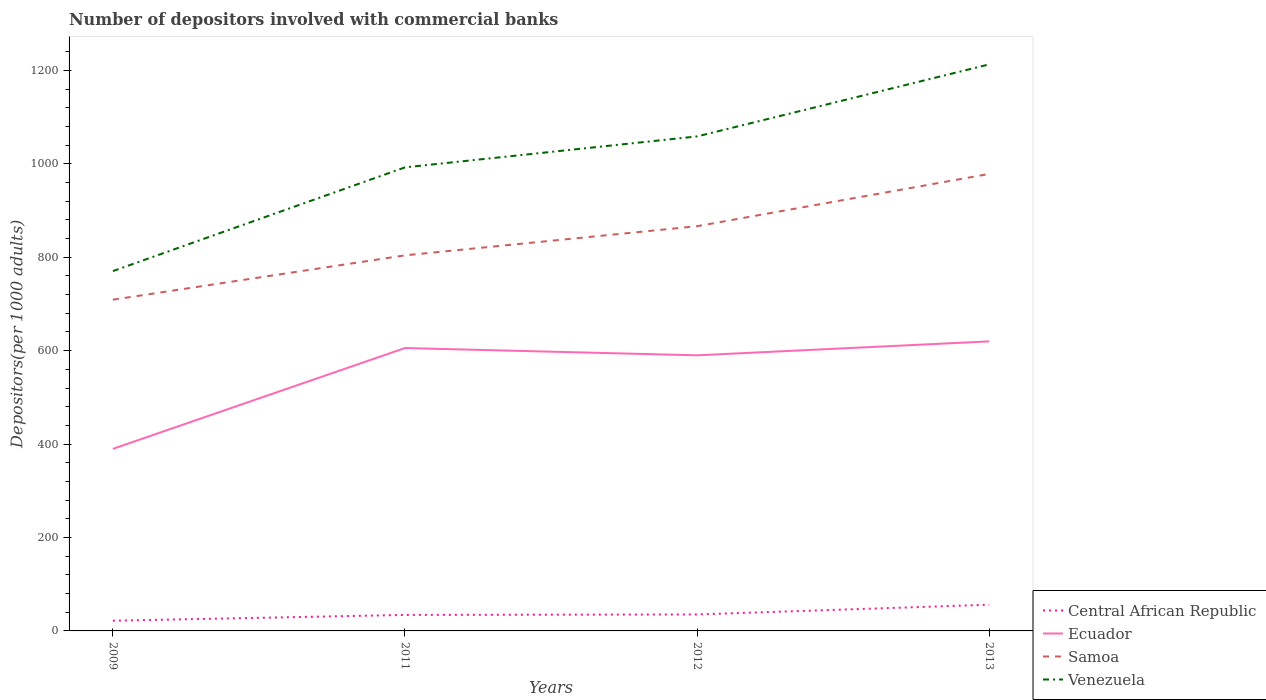Across all years, what is the maximum number of depositors involved with commercial banks in Central African Republic?
Ensure brevity in your answer.  21.85. What is the total number of depositors involved with commercial banks in Central African Republic in the graph?
Give a very brief answer. -12.4. What is the difference between the highest and the second highest number of depositors involved with commercial banks in Central African Republic?
Give a very brief answer. 34.25. What is the difference between the highest and the lowest number of depositors involved with commercial banks in Samoa?
Your answer should be very brief. 2. How many lines are there?
Make the answer very short. 4. How many years are there in the graph?
Your answer should be very brief. 4. What is the difference between two consecutive major ticks on the Y-axis?
Your answer should be very brief. 200. What is the title of the graph?
Your answer should be compact. Number of depositors involved with commercial banks. Does "Liechtenstein" appear as one of the legend labels in the graph?
Your answer should be compact. No. What is the label or title of the Y-axis?
Keep it short and to the point. Depositors(per 1000 adults). What is the Depositors(per 1000 adults) in Central African Republic in 2009?
Keep it short and to the point. 21.85. What is the Depositors(per 1000 adults) of Ecuador in 2009?
Offer a very short reply. 389.78. What is the Depositors(per 1000 adults) of Samoa in 2009?
Offer a terse response. 709.09. What is the Depositors(per 1000 adults) of Venezuela in 2009?
Provide a succinct answer. 770.33. What is the Depositors(per 1000 adults) of Central African Republic in 2011?
Make the answer very short. 34.26. What is the Depositors(per 1000 adults) of Ecuador in 2011?
Provide a succinct answer. 605.63. What is the Depositors(per 1000 adults) of Samoa in 2011?
Keep it short and to the point. 804.04. What is the Depositors(per 1000 adults) of Venezuela in 2011?
Make the answer very short. 992.39. What is the Depositors(per 1000 adults) in Central African Republic in 2012?
Offer a terse response. 35.28. What is the Depositors(per 1000 adults) of Ecuador in 2012?
Your answer should be very brief. 590.02. What is the Depositors(per 1000 adults) of Samoa in 2012?
Ensure brevity in your answer.  866.45. What is the Depositors(per 1000 adults) of Venezuela in 2012?
Keep it short and to the point. 1058.65. What is the Depositors(per 1000 adults) in Central African Republic in 2013?
Your response must be concise. 56.1. What is the Depositors(per 1000 adults) of Ecuador in 2013?
Offer a terse response. 619.83. What is the Depositors(per 1000 adults) in Samoa in 2013?
Offer a very short reply. 978.35. What is the Depositors(per 1000 adults) in Venezuela in 2013?
Your answer should be very brief. 1212.85. Across all years, what is the maximum Depositors(per 1000 adults) of Central African Republic?
Ensure brevity in your answer.  56.1. Across all years, what is the maximum Depositors(per 1000 adults) of Ecuador?
Provide a succinct answer. 619.83. Across all years, what is the maximum Depositors(per 1000 adults) of Samoa?
Ensure brevity in your answer.  978.35. Across all years, what is the maximum Depositors(per 1000 adults) of Venezuela?
Provide a succinct answer. 1212.85. Across all years, what is the minimum Depositors(per 1000 adults) of Central African Republic?
Give a very brief answer. 21.85. Across all years, what is the minimum Depositors(per 1000 adults) of Ecuador?
Ensure brevity in your answer.  389.78. Across all years, what is the minimum Depositors(per 1000 adults) in Samoa?
Your response must be concise. 709.09. Across all years, what is the minimum Depositors(per 1000 adults) in Venezuela?
Make the answer very short. 770.33. What is the total Depositors(per 1000 adults) in Central African Republic in the graph?
Your response must be concise. 147.48. What is the total Depositors(per 1000 adults) in Ecuador in the graph?
Keep it short and to the point. 2205.27. What is the total Depositors(per 1000 adults) of Samoa in the graph?
Give a very brief answer. 3357.94. What is the total Depositors(per 1000 adults) of Venezuela in the graph?
Your response must be concise. 4034.22. What is the difference between the Depositors(per 1000 adults) in Central African Republic in 2009 and that in 2011?
Make the answer very short. -12.4. What is the difference between the Depositors(per 1000 adults) in Ecuador in 2009 and that in 2011?
Offer a very short reply. -215.85. What is the difference between the Depositors(per 1000 adults) of Samoa in 2009 and that in 2011?
Offer a very short reply. -94.95. What is the difference between the Depositors(per 1000 adults) in Venezuela in 2009 and that in 2011?
Offer a terse response. -222.05. What is the difference between the Depositors(per 1000 adults) in Central African Republic in 2009 and that in 2012?
Provide a short and direct response. -13.43. What is the difference between the Depositors(per 1000 adults) of Ecuador in 2009 and that in 2012?
Your answer should be compact. -200.24. What is the difference between the Depositors(per 1000 adults) in Samoa in 2009 and that in 2012?
Give a very brief answer. -157.36. What is the difference between the Depositors(per 1000 adults) in Venezuela in 2009 and that in 2012?
Your answer should be very brief. -288.32. What is the difference between the Depositors(per 1000 adults) of Central African Republic in 2009 and that in 2013?
Offer a terse response. -34.25. What is the difference between the Depositors(per 1000 adults) of Ecuador in 2009 and that in 2013?
Offer a very short reply. -230.05. What is the difference between the Depositors(per 1000 adults) of Samoa in 2009 and that in 2013?
Keep it short and to the point. -269.26. What is the difference between the Depositors(per 1000 adults) of Venezuela in 2009 and that in 2013?
Make the answer very short. -442.51. What is the difference between the Depositors(per 1000 adults) in Central African Republic in 2011 and that in 2012?
Provide a short and direct response. -1.02. What is the difference between the Depositors(per 1000 adults) of Ecuador in 2011 and that in 2012?
Your answer should be very brief. 15.61. What is the difference between the Depositors(per 1000 adults) of Samoa in 2011 and that in 2012?
Your response must be concise. -62.41. What is the difference between the Depositors(per 1000 adults) of Venezuela in 2011 and that in 2012?
Offer a very short reply. -66.26. What is the difference between the Depositors(per 1000 adults) of Central African Republic in 2011 and that in 2013?
Provide a short and direct response. -21.84. What is the difference between the Depositors(per 1000 adults) in Ecuador in 2011 and that in 2013?
Ensure brevity in your answer.  -14.2. What is the difference between the Depositors(per 1000 adults) of Samoa in 2011 and that in 2013?
Ensure brevity in your answer.  -174.3. What is the difference between the Depositors(per 1000 adults) in Venezuela in 2011 and that in 2013?
Give a very brief answer. -220.46. What is the difference between the Depositors(per 1000 adults) of Central African Republic in 2012 and that in 2013?
Your answer should be compact. -20.82. What is the difference between the Depositors(per 1000 adults) in Ecuador in 2012 and that in 2013?
Make the answer very short. -29.81. What is the difference between the Depositors(per 1000 adults) of Samoa in 2012 and that in 2013?
Your answer should be very brief. -111.9. What is the difference between the Depositors(per 1000 adults) of Venezuela in 2012 and that in 2013?
Offer a very short reply. -154.19. What is the difference between the Depositors(per 1000 adults) of Central African Republic in 2009 and the Depositors(per 1000 adults) of Ecuador in 2011?
Make the answer very short. -583.78. What is the difference between the Depositors(per 1000 adults) of Central African Republic in 2009 and the Depositors(per 1000 adults) of Samoa in 2011?
Offer a very short reply. -782.19. What is the difference between the Depositors(per 1000 adults) in Central African Republic in 2009 and the Depositors(per 1000 adults) in Venezuela in 2011?
Provide a short and direct response. -970.54. What is the difference between the Depositors(per 1000 adults) in Ecuador in 2009 and the Depositors(per 1000 adults) in Samoa in 2011?
Provide a short and direct response. -414.26. What is the difference between the Depositors(per 1000 adults) in Ecuador in 2009 and the Depositors(per 1000 adults) in Venezuela in 2011?
Keep it short and to the point. -602.6. What is the difference between the Depositors(per 1000 adults) in Samoa in 2009 and the Depositors(per 1000 adults) in Venezuela in 2011?
Your answer should be very brief. -283.3. What is the difference between the Depositors(per 1000 adults) in Central African Republic in 2009 and the Depositors(per 1000 adults) in Ecuador in 2012?
Offer a very short reply. -568.17. What is the difference between the Depositors(per 1000 adults) in Central African Republic in 2009 and the Depositors(per 1000 adults) in Samoa in 2012?
Provide a succinct answer. -844.6. What is the difference between the Depositors(per 1000 adults) in Central African Republic in 2009 and the Depositors(per 1000 adults) in Venezuela in 2012?
Offer a very short reply. -1036.8. What is the difference between the Depositors(per 1000 adults) of Ecuador in 2009 and the Depositors(per 1000 adults) of Samoa in 2012?
Offer a very short reply. -476.67. What is the difference between the Depositors(per 1000 adults) in Ecuador in 2009 and the Depositors(per 1000 adults) in Venezuela in 2012?
Provide a short and direct response. -668.87. What is the difference between the Depositors(per 1000 adults) of Samoa in 2009 and the Depositors(per 1000 adults) of Venezuela in 2012?
Provide a short and direct response. -349.56. What is the difference between the Depositors(per 1000 adults) of Central African Republic in 2009 and the Depositors(per 1000 adults) of Ecuador in 2013?
Your answer should be very brief. -597.98. What is the difference between the Depositors(per 1000 adults) in Central African Republic in 2009 and the Depositors(per 1000 adults) in Samoa in 2013?
Make the answer very short. -956.5. What is the difference between the Depositors(per 1000 adults) in Central African Republic in 2009 and the Depositors(per 1000 adults) in Venezuela in 2013?
Make the answer very short. -1190.99. What is the difference between the Depositors(per 1000 adults) of Ecuador in 2009 and the Depositors(per 1000 adults) of Samoa in 2013?
Offer a terse response. -588.57. What is the difference between the Depositors(per 1000 adults) in Ecuador in 2009 and the Depositors(per 1000 adults) in Venezuela in 2013?
Give a very brief answer. -823.06. What is the difference between the Depositors(per 1000 adults) in Samoa in 2009 and the Depositors(per 1000 adults) in Venezuela in 2013?
Your answer should be very brief. -503.75. What is the difference between the Depositors(per 1000 adults) in Central African Republic in 2011 and the Depositors(per 1000 adults) in Ecuador in 2012?
Provide a succinct answer. -555.77. What is the difference between the Depositors(per 1000 adults) of Central African Republic in 2011 and the Depositors(per 1000 adults) of Samoa in 2012?
Offer a terse response. -832.2. What is the difference between the Depositors(per 1000 adults) in Central African Republic in 2011 and the Depositors(per 1000 adults) in Venezuela in 2012?
Make the answer very short. -1024.4. What is the difference between the Depositors(per 1000 adults) of Ecuador in 2011 and the Depositors(per 1000 adults) of Samoa in 2012?
Your answer should be very brief. -260.82. What is the difference between the Depositors(per 1000 adults) in Ecuador in 2011 and the Depositors(per 1000 adults) in Venezuela in 2012?
Provide a short and direct response. -453.02. What is the difference between the Depositors(per 1000 adults) in Samoa in 2011 and the Depositors(per 1000 adults) in Venezuela in 2012?
Offer a terse response. -254.61. What is the difference between the Depositors(per 1000 adults) in Central African Republic in 2011 and the Depositors(per 1000 adults) in Ecuador in 2013?
Your response must be concise. -585.57. What is the difference between the Depositors(per 1000 adults) of Central African Republic in 2011 and the Depositors(per 1000 adults) of Samoa in 2013?
Offer a terse response. -944.09. What is the difference between the Depositors(per 1000 adults) in Central African Republic in 2011 and the Depositors(per 1000 adults) in Venezuela in 2013?
Your response must be concise. -1178.59. What is the difference between the Depositors(per 1000 adults) of Ecuador in 2011 and the Depositors(per 1000 adults) of Samoa in 2013?
Your answer should be compact. -372.71. What is the difference between the Depositors(per 1000 adults) in Ecuador in 2011 and the Depositors(per 1000 adults) in Venezuela in 2013?
Make the answer very short. -607.21. What is the difference between the Depositors(per 1000 adults) in Samoa in 2011 and the Depositors(per 1000 adults) in Venezuela in 2013?
Your answer should be very brief. -408.8. What is the difference between the Depositors(per 1000 adults) of Central African Republic in 2012 and the Depositors(per 1000 adults) of Ecuador in 2013?
Offer a terse response. -584.55. What is the difference between the Depositors(per 1000 adults) in Central African Republic in 2012 and the Depositors(per 1000 adults) in Samoa in 2013?
Offer a very short reply. -943.07. What is the difference between the Depositors(per 1000 adults) in Central African Republic in 2012 and the Depositors(per 1000 adults) in Venezuela in 2013?
Keep it short and to the point. -1177.57. What is the difference between the Depositors(per 1000 adults) of Ecuador in 2012 and the Depositors(per 1000 adults) of Samoa in 2013?
Give a very brief answer. -388.33. What is the difference between the Depositors(per 1000 adults) in Ecuador in 2012 and the Depositors(per 1000 adults) in Venezuela in 2013?
Provide a short and direct response. -622.82. What is the difference between the Depositors(per 1000 adults) in Samoa in 2012 and the Depositors(per 1000 adults) in Venezuela in 2013?
Ensure brevity in your answer.  -346.39. What is the average Depositors(per 1000 adults) of Central African Republic per year?
Your answer should be very brief. 36.87. What is the average Depositors(per 1000 adults) of Ecuador per year?
Provide a short and direct response. 551.32. What is the average Depositors(per 1000 adults) of Samoa per year?
Provide a succinct answer. 839.48. What is the average Depositors(per 1000 adults) of Venezuela per year?
Keep it short and to the point. 1008.55. In the year 2009, what is the difference between the Depositors(per 1000 adults) of Central African Republic and Depositors(per 1000 adults) of Ecuador?
Give a very brief answer. -367.93. In the year 2009, what is the difference between the Depositors(per 1000 adults) of Central African Republic and Depositors(per 1000 adults) of Samoa?
Give a very brief answer. -687.24. In the year 2009, what is the difference between the Depositors(per 1000 adults) in Central African Republic and Depositors(per 1000 adults) in Venezuela?
Ensure brevity in your answer.  -748.48. In the year 2009, what is the difference between the Depositors(per 1000 adults) in Ecuador and Depositors(per 1000 adults) in Samoa?
Your response must be concise. -319.31. In the year 2009, what is the difference between the Depositors(per 1000 adults) of Ecuador and Depositors(per 1000 adults) of Venezuela?
Give a very brief answer. -380.55. In the year 2009, what is the difference between the Depositors(per 1000 adults) of Samoa and Depositors(per 1000 adults) of Venezuela?
Offer a terse response. -61.24. In the year 2011, what is the difference between the Depositors(per 1000 adults) of Central African Republic and Depositors(per 1000 adults) of Ecuador?
Keep it short and to the point. -571.38. In the year 2011, what is the difference between the Depositors(per 1000 adults) of Central African Republic and Depositors(per 1000 adults) of Samoa?
Keep it short and to the point. -769.79. In the year 2011, what is the difference between the Depositors(per 1000 adults) in Central African Republic and Depositors(per 1000 adults) in Venezuela?
Provide a succinct answer. -958.13. In the year 2011, what is the difference between the Depositors(per 1000 adults) of Ecuador and Depositors(per 1000 adults) of Samoa?
Keep it short and to the point. -198.41. In the year 2011, what is the difference between the Depositors(per 1000 adults) of Ecuador and Depositors(per 1000 adults) of Venezuela?
Offer a terse response. -386.75. In the year 2011, what is the difference between the Depositors(per 1000 adults) in Samoa and Depositors(per 1000 adults) in Venezuela?
Ensure brevity in your answer.  -188.34. In the year 2012, what is the difference between the Depositors(per 1000 adults) of Central African Republic and Depositors(per 1000 adults) of Ecuador?
Your answer should be very brief. -554.74. In the year 2012, what is the difference between the Depositors(per 1000 adults) in Central African Republic and Depositors(per 1000 adults) in Samoa?
Make the answer very short. -831.17. In the year 2012, what is the difference between the Depositors(per 1000 adults) in Central African Republic and Depositors(per 1000 adults) in Venezuela?
Your answer should be very brief. -1023.37. In the year 2012, what is the difference between the Depositors(per 1000 adults) of Ecuador and Depositors(per 1000 adults) of Samoa?
Make the answer very short. -276.43. In the year 2012, what is the difference between the Depositors(per 1000 adults) of Ecuador and Depositors(per 1000 adults) of Venezuela?
Ensure brevity in your answer.  -468.63. In the year 2012, what is the difference between the Depositors(per 1000 adults) of Samoa and Depositors(per 1000 adults) of Venezuela?
Give a very brief answer. -192.2. In the year 2013, what is the difference between the Depositors(per 1000 adults) in Central African Republic and Depositors(per 1000 adults) in Ecuador?
Provide a succinct answer. -563.73. In the year 2013, what is the difference between the Depositors(per 1000 adults) in Central African Republic and Depositors(per 1000 adults) in Samoa?
Offer a terse response. -922.25. In the year 2013, what is the difference between the Depositors(per 1000 adults) in Central African Republic and Depositors(per 1000 adults) in Venezuela?
Provide a succinct answer. -1156.75. In the year 2013, what is the difference between the Depositors(per 1000 adults) in Ecuador and Depositors(per 1000 adults) in Samoa?
Offer a terse response. -358.52. In the year 2013, what is the difference between the Depositors(per 1000 adults) in Ecuador and Depositors(per 1000 adults) in Venezuela?
Ensure brevity in your answer.  -593.02. In the year 2013, what is the difference between the Depositors(per 1000 adults) in Samoa and Depositors(per 1000 adults) in Venezuela?
Provide a short and direct response. -234.5. What is the ratio of the Depositors(per 1000 adults) of Central African Republic in 2009 to that in 2011?
Your answer should be very brief. 0.64. What is the ratio of the Depositors(per 1000 adults) of Ecuador in 2009 to that in 2011?
Make the answer very short. 0.64. What is the ratio of the Depositors(per 1000 adults) in Samoa in 2009 to that in 2011?
Offer a very short reply. 0.88. What is the ratio of the Depositors(per 1000 adults) of Venezuela in 2009 to that in 2011?
Offer a very short reply. 0.78. What is the ratio of the Depositors(per 1000 adults) in Central African Republic in 2009 to that in 2012?
Your response must be concise. 0.62. What is the ratio of the Depositors(per 1000 adults) in Ecuador in 2009 to that in 2012?
Provide a short and direct response. 0.66. What is the ratio of the Depositors(per 1000 adults) in Samoa in 2009 to that in 2012?
Provide a short and direct response. 0.82. What is the ratio of the Depositors(per 1000 adults) in Venezuela in 2009 to that in 2012?
Your answer should be compact. 0.73. What is the ratio of the Depositors(per 1000 adults) of Central African Republic in 2009 to that in 2013?
Keep it short and to the point. 0.39. What is the ratio of the Depositors(per 1000 adults) in Ecuador in 2009 to that in 2013?
Offer a terse response. 0.63. What is the ratio of the Depositors(per 1000 adults) in Samoa in 2009 to that in 2013?
Offer a very short reply. 0.72. What is the ratio of the Depositors(per 1000 adults) in Venezuela in 2009 to that in 2013?
Provide a succinct answer. 0.64. What is the ratio of the Depositors(per 1000 adults) of Central African Republic in 2011 to that in 2012?
Offer a very short reply. 0.97. What is the ratio of the Depositors(per 1000 adults) of Ecuador in 2011 to that in 2012?
Make the answer very short. 1.03. What is the ratio of the Depositors(per 1000 adults) in Samoa in 2011 to that in 2012?
Offer a very short reply. 0.93. What is the ratio of the Depositors(per 1000 adults) of Venezuela in 2011 to that in 2012?
Provide a short and direct response. 0.94. What is the ratio of the Depositors(per 1000 adults) in Central African Republic in 2011 to that in 2013?
Offer a terse response. 0.61. What is the ratio of the Depositors(per 1000 adults) of Ecuador in 2011 to that in 2013?
Keep it short and to the point. 0.98. What is the ratio of the Depositors(per 1000 adults) in Samoa in 2011 to that in 2013?
Provide a succinct answer. 0.82. What is the ratio of the Depositors(per 1000 adults) in Venezuela in 2011 to that in 2013?
Make the answer very short. 0.82. What is the ratio of the Depositors(per 1000 adults) in Central African Republic in 2012 to that in 2013?
Your answer should be compact. 0.63. What is the ratio of the Depositors(per 1000 adults) in Ecuador in 2012 to that in 2013?
Ensure brevity in your answer.  0.95. What is the ratio of the Depositors(per 1000 adults) of Samoa in 2012 to that in 2013?
Ensure brevity in your answer.  0.89. What is the ratio of the Depositors(per 1000 adults) of Venezuela in 2012 to that in 2013?
Offer a very short reply. 0.87. What is the difference between the highest and the second highest Depositors(per 1000 adults) of Central African Republic?
Provide a succinct answer. 20.82. What is the difference between the highest and the second highest Depositors(per 1000 adults) in Ecuador?
Provide a succinct answer. 14.2. What is the difference between the highest and the second highest Depositors(per 1000 adults) of Samoa?
Your answer should be very brief. 111.9. What is the difference between the highest and the second highest Depositors(per 1000 adults) of Venezuela?
Ensure brevity in your answer.  154.19. What is the difference between the highest and the lowest Depositors(per 1000 adults) of Central African Republic?
Give a very brief answer. 34.25. What is the difference between the highest and the lowest Depositors(per 1000 adults) in Ecuador?
Make the answer very short. 230.05. What is the difference between the highest and the lowest Depositors(per 1000 adults) of Samoa?
Keep it short and to the point. 269.26. What is the difference between the highest and the lowest Depositors(per 1000 adults) of Venezuela?
Offer a terse response. 442.51. 